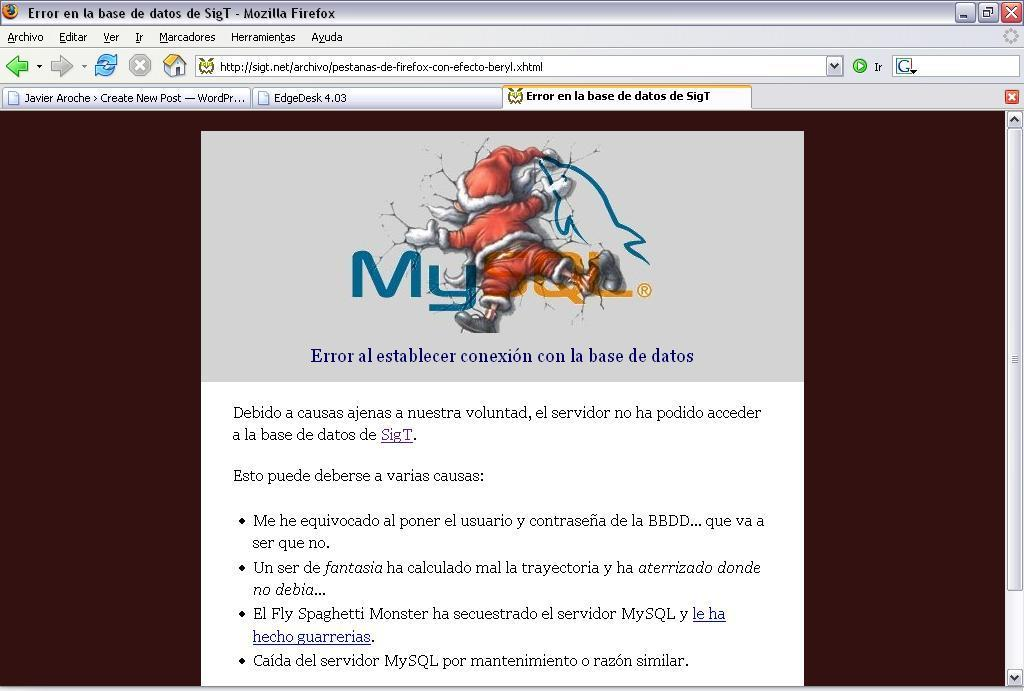What type of image is shown in the screenshot? The image is a screenshot of a screen. What can be seen at the top of the screenshot? There are icons visible at the top of the screenshot. Can you describe the main subject of the image? There is a red color Santa Claus in the image. Is there any text or writing on the Santa Claus? Yes, something is written on the Santa Claus. How many cacti are present in the image? There are no cacti present in the image. What type of pets can be seen interacting with the Santa Claus in the image? There are no pets visible in the image. 